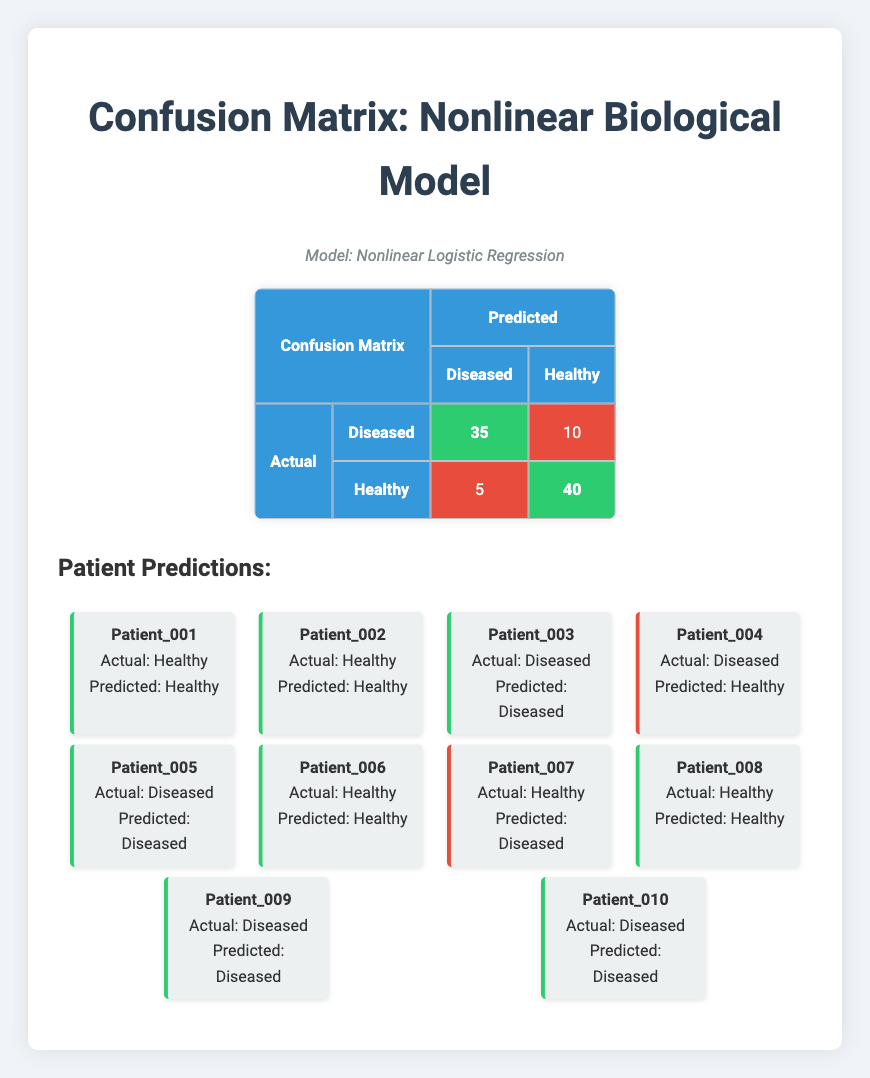What is the value for true positives in this confusion matrix? The confusion matrix states that the number of true positives is 35, which represents the count of correctly identified diseased patients.
Answer: 35 What is the sum of false positives and false negatives? The confusion matrix shows that there are 5 false positives and 10 false negatives. Adding these two values gives 5 + 10 = 15.
Answer: 15 What percentage of the patients were correctly classified as healthy? From the confusion matrix, the number of true negatives is 40 (correctly predicted healthy cases) and false negatives is 10 (incorrectly predicted diseased cases). The total number of healthy patients is therefore 40 + 10 = 50. The percentage is (40/50) * 100 = 80%.
Answer: 80% Are there more true positives than false negatives in this model? The confusion matrix indicates that there are 35 true positives and 10 false negatives. Since 35 is greater than 10, the statement is true.
Answer: Yes How many patients were falsely labeled as healthy? The confusion matrix indicates that there are 5 false positives, which corresponds to patients who were actually diseased but predicted as healthy.
Answer: 5 What is the average number of predictions for diseased patients based on this model? From the confusion matrix, there are 35 true positives (diseased correctly predicted) and 10 false negatives (diseased incorrectly predicted), giving a total of 35 + 10 = 45. To find the average, this value is divided by 2, resulting in 45 / 2 = 22.5.
Answer: 22.5 How many patients were correctly identified as diseased? The confusion matrix lists 35 true positives, representing the number of diseased patients who were correctly predicted as diseased.
Answer: 35 What is the difference between true negatives and false positives? The confusion matrix states there are 40 true negatives and 5 false positives. To find the difference, subtract the number of false positives from true negatives, which is 40 - 5 = 35.
Answer: 35 How many patients were correctly predicted overall? The total number of correctly predicted patients consists of true positives (35) and true negatives (40). Adding these gives a total of 35 + 40 = 75.
Answer: 75 